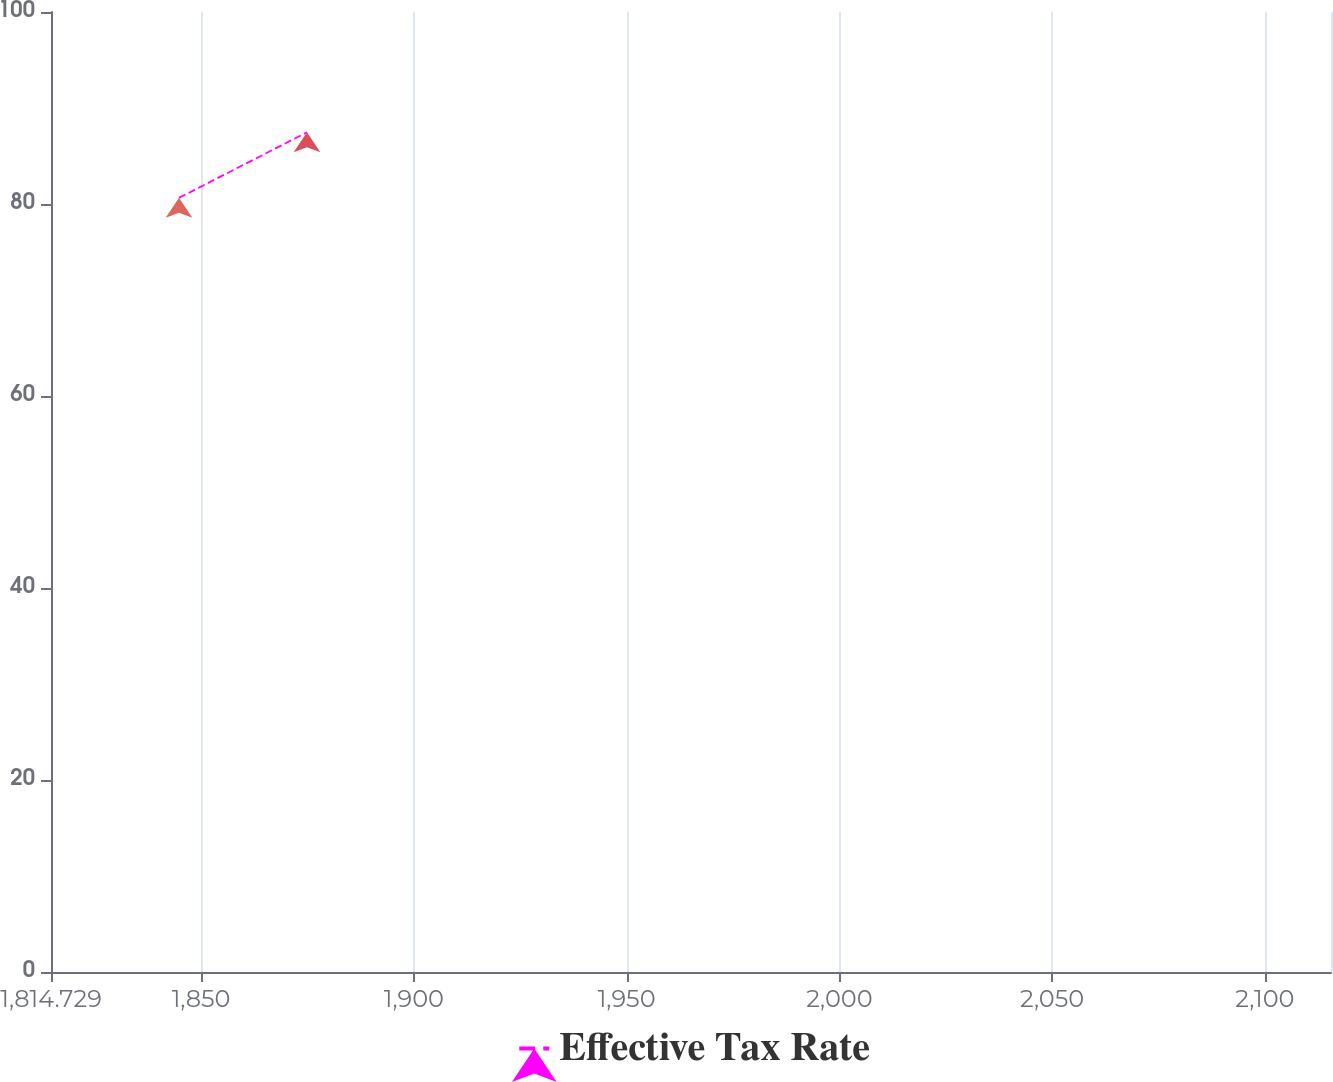<chart> <loc_0><loc_0><loc_500><loc_500><line_chart><ecel><fcel>Effective Tax Rate<nl><fcel>1844.81<fcel>80.64<nl><fcel>1874.89<fcel>87.47<nl><fcel>2145.62<fcel>21.19<nl></chart> 